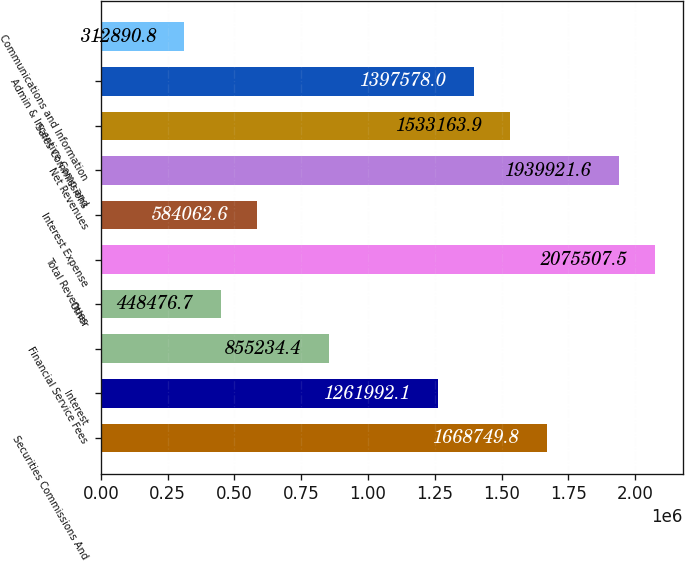Convert chart. <chart><loc_0><loc_0><loc_500><loc_500><bar_chart><fcel>Securities Commissions And<fcel>Interest<fcel>Financial Service Fees<fcel>Other<fcel>Total Revenues<fcel>Interest Expense<fcel>Net Revenues<fcel>Sales Commissions<fcel>Admin & Incentive Comp and<fcel>Communications and Information<nl><fcel>1.66875e+06<fcel>1.26199e+06<fcel>855234<fcel>448477<fcel>2.07551e+06<fcel>584063<fcel>1.93992e+06<fcel>1.53316e+06<fcel>1.39758e+06<fcel>312891<nl></chart> 